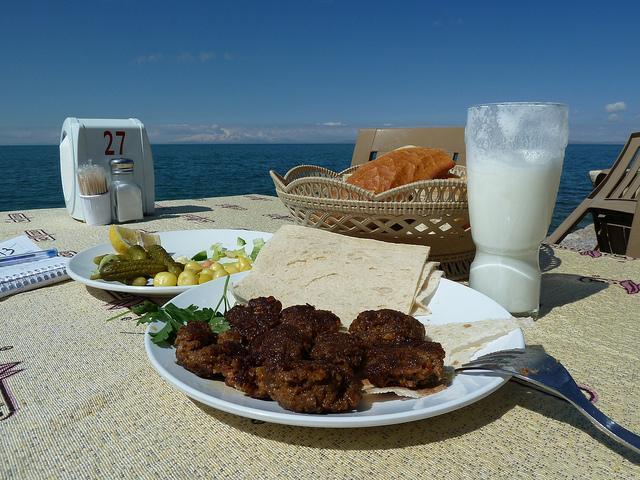How many chairs are visible?
Give a very brief answer. 2. How many dining tables can you see?
Give a very brief answer. 1. 